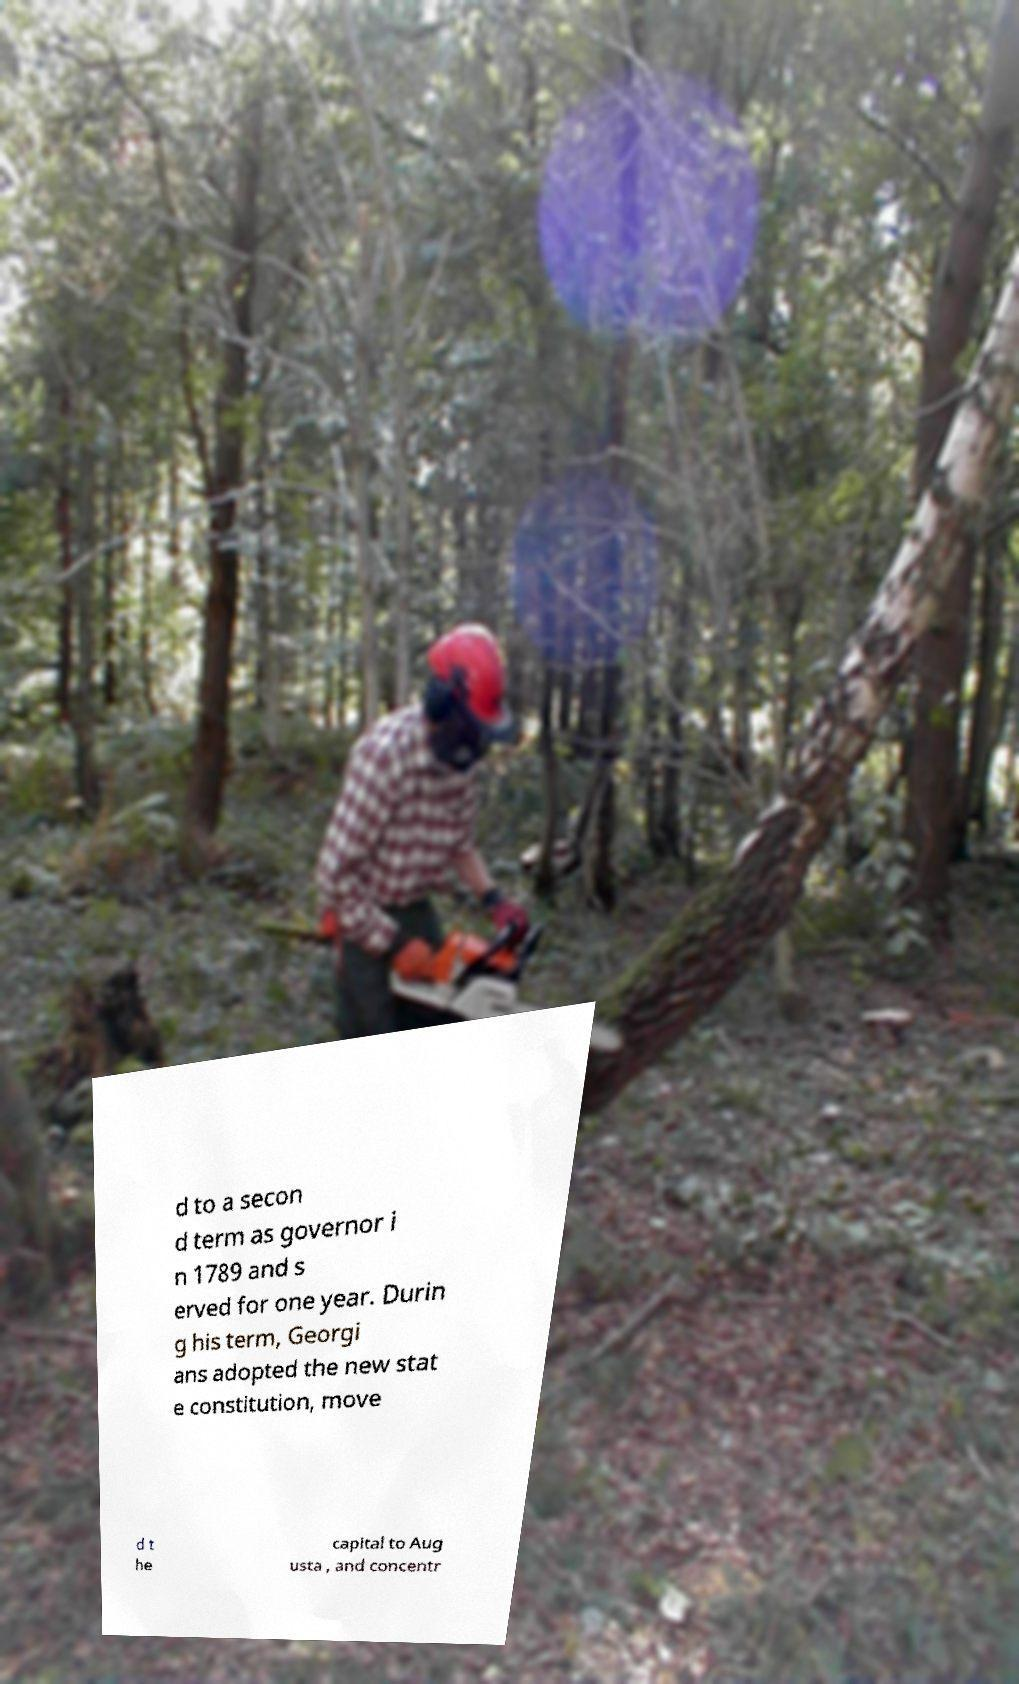I need the written content from this picture converted into text. Can you do that? d to a secon d term as governor i n 1789 and s erved for one year. Durin g his term, Georgi ans adopted the new stat e constitution, move d t he capital to Aug usta , and concentr 